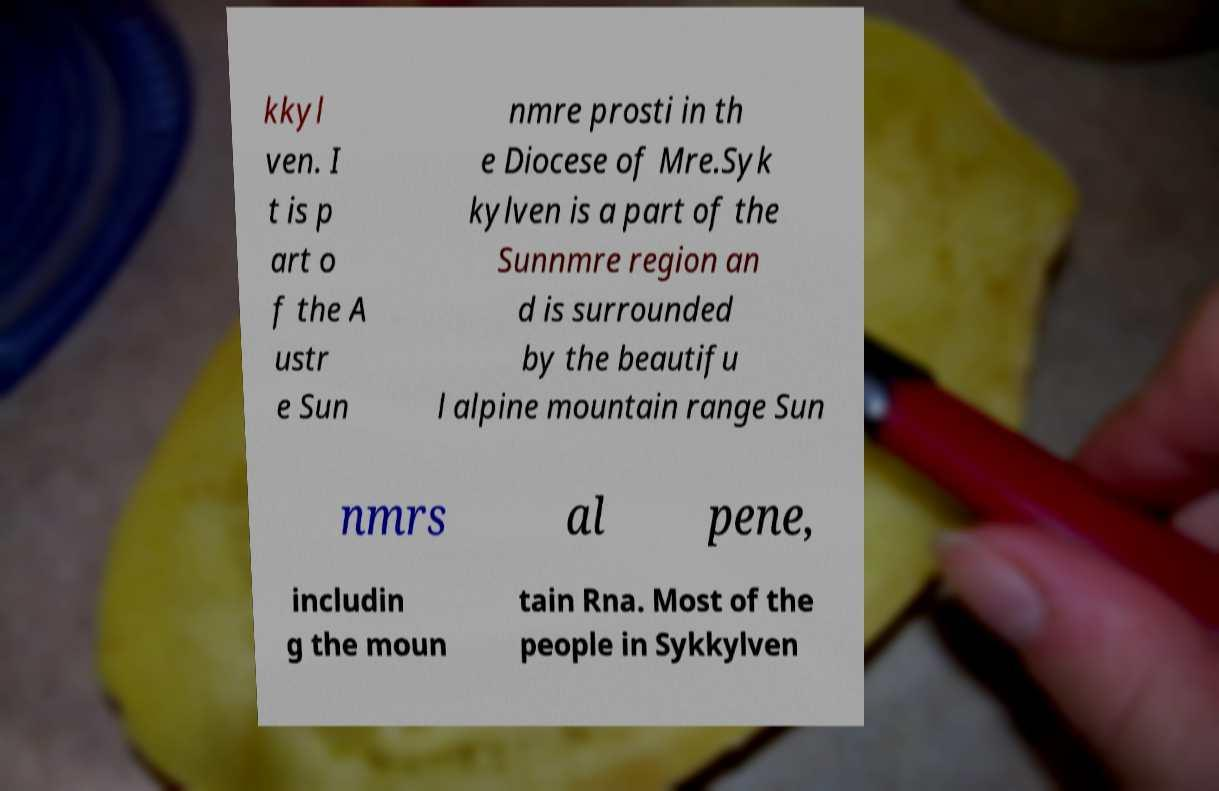Could you assist in decoding the text presented in this image and type it out clearly? kkyl ven. I t is p art o f the A ustr e Sun nmre prosti in th e Diocese of Mre.Syk kylven is a part of the Sunnmre region an d is surrounded by the beautifu l alpine mountain range Sun nmrs al pene, includin g the moun tain Rna. Most of the people in Sykkylven 